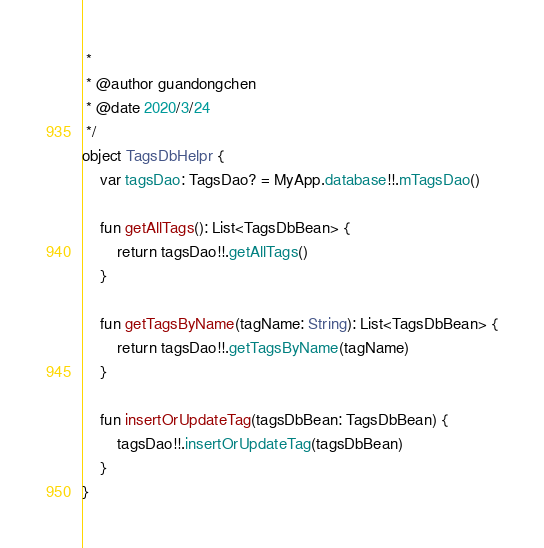Convert code to text. <code><loc_0><loc_0><loc_500><loc_500><_Kotlin_> *
 * @author guandongchen
 * @date 2020/3/24
 */
object TagsDbHelpr {
    var tagsDao: TagsDao? = MyApp.database!!.mTagsDao()

    fun getAllTags(): List<TagsDbBean> {
        return tagsDao!!.getAllTags()
    }

    fun getTagsByName(tagName: String): List<TagsDbBean> {
        return tagsDao!!.getTagsByName(tagName)
    }

    fun insertOrUpdateTag(tagsDbBean: TagsDbBean) {
        tagsDao!!.insertOrUpdateTag(tagsDbBean)
    }
}</code> 